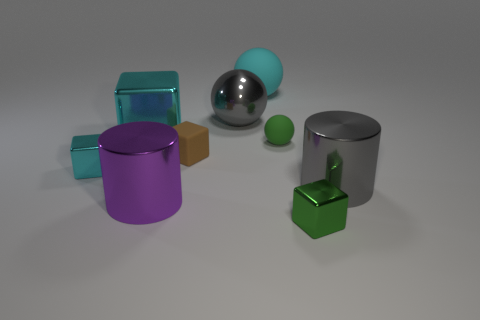How many cyan blocks must be subtracted to get 1 cyan blocks? 1 Add 1 small objects. How many objects exist? 10 Subtract all spheres. How many objects are left? 6 Subtract 0 yellow cylinders. How many objects are left? 9 Subtract all large cylinders. Subtract all large cyan metal blocks. How many objects are left? 6 Add 8 tiny metal things. How many tiny metal things are left? 10 Add 3 green matte objects. How many green matte objects exist? 4 